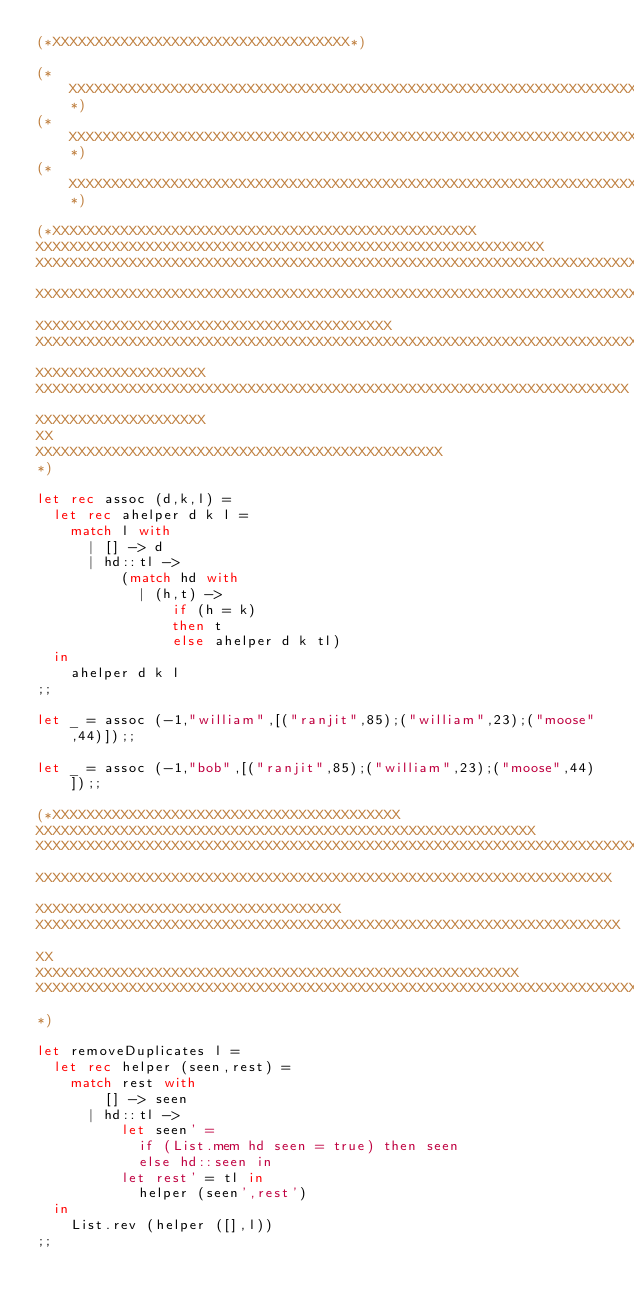<code> <loc_0><loc_0><loc_500><loc_500><_OCaml_>(*XXXXXXXXXXXXXXXXXXXXXXXXXXXXXXXXXXX*)

(*XXXXXXXXXXXXXXXXXXXXXXXXXXXXXXXXXXXXXXXXXXXXXXXXXXXXXXXXXXXXXXXXXXXXXXXXXXXXXXXXXXXXXX*)
(*XXXXXXXXXXXXXXXXXXXXXXXXXXXXXXXXXXXXXXXXXXXXXXXXXXXXXXXXXXXXXXXXXXXXXXXXXXXXXXXXXXXXXX*)
(*XXXXXXXXXXXXXXXXXXXXXXXXXXXXXXXXXXXXXXXXXXXXXXXXXXXXXXXXXXXXXXXXXXXXXXXXXXXXXXXXXXXXXX*)

(*XXXXXXXXXXXXXXXXXXXXXXXXXXXXXXXXXXXXXXXXXXXXXXXXXX
XXXXXXXXXXXXXXXXXXXXXXXXXXXXXXXXXXXXXXXXXXXXXXXXXXXXXXXXXXXX
XXXXXXXXXXXXXXXXXXXXXXXXXXXXXXXXXXXXXXXXXXXXXXXXXXXXXXXXXXXXXXXXXXXXXXXXXXXXXXXXXXX
XXXXXXXXXXXXXXXXXXXXXXXXXXXXXXXXXXXXXXXXXXXXXXXXXXXXXXXXXXXXXXXXXXXXXXXXXXXXXXXXXXXXX
XXXXXXXXXXXXXXXXXXXXXXXXXXXXXXXXXXXXXXXXXX
XXXXXXXXXXXXXXXXXXXXXXXXXXXXXXXXXXXXXXXXXXXXXXXXXXXXXXXXXXXXXXXXXXXXXXXXXX
XXXXXXXXXXXXXXXXXXXX
XXXXXXXXXXXXXXXXXXXXXXXXXXXXXXXXXXXXXXXXXXXXXXXXXXXXXXXXXXXXXXXXXXXXXX
XXXXXXXXXXXXXXXXXXXX
XX
XXXXXXXXXXXXXXXXXXXXXXXXXXXXXXXXXXXXXXXXXXXXXXXX
*)

let rec assoc (d,k,l) =
  let rec ahelper d k l = 
    match l with
      | [] -> d
      | hd::tl ->
          (match hd with
            | (h,t) ->
                if (h = k)
                then t
                else ahelper d k tl)
  in
    ahelper d k l
;;

let _ = assoc (-1,"william",[("ranjit",85);("william",23);("moose",44)]);;    

let _ = assoc (-1,"bob",[("ranjit",85);("william",23);("moose",44)]);;

(*XXXXXXXXXXXXXXXXXXXXXXXXXXXXXXXXXXXXXXXXX
XXXXXXXXXXXXXXXXXXXXXXXXXXXXXXXXXXXXXXXXXXXXXXXXXXXXXXXXXXX
XXXXXXXXXXXXXXXXXXXXXXXXXXXXXXXXXXXXXXXXXXXXXXXXXXXXXXXXXXXXXXXXXXXXXXXXXXXXX
XXXXXXXXXXXXXXXXXXXXXXXXXXXXXXXXXXXXXXXXXXXXXXXXXXXXXXXXXXXXXXXXXXXX
XXXXXXXXXXXXXXXXXXXXXXXXXXXXXXXXXXXX
XXXXXXXXXXXXXXXXXXXXXXXXXXXXXXXXXXXXXXXXXXXXXXXXXXXXXXXXXXXXXXXXXXXXX
XX
XXXXXXXXXXXXXXXXXXXXXXXXXXXXXXXXXXXXXXXXXXXXXXXXXXXXXXXXX
XXXXXXXXXXXXXXXXXXXXXXXXXXXXXXXXXXXXXXXXXXXXXXXXXXXXXXXXXXXXXXXXXXXXXXXXXXXXXXXX
*)

let removeDuplicates l = 
  let rec helper (seen,rest) = 
    match rest with 
        [] -> seen
      | hd::tl -> 
          let seen' = 
            if (List.mem hd seen = true) then seen
            else hd::seen in
          let rest' = tl in 
            helper (seen',rest') 
  in
    List.rev (helper ([],l))
;;
</code> 